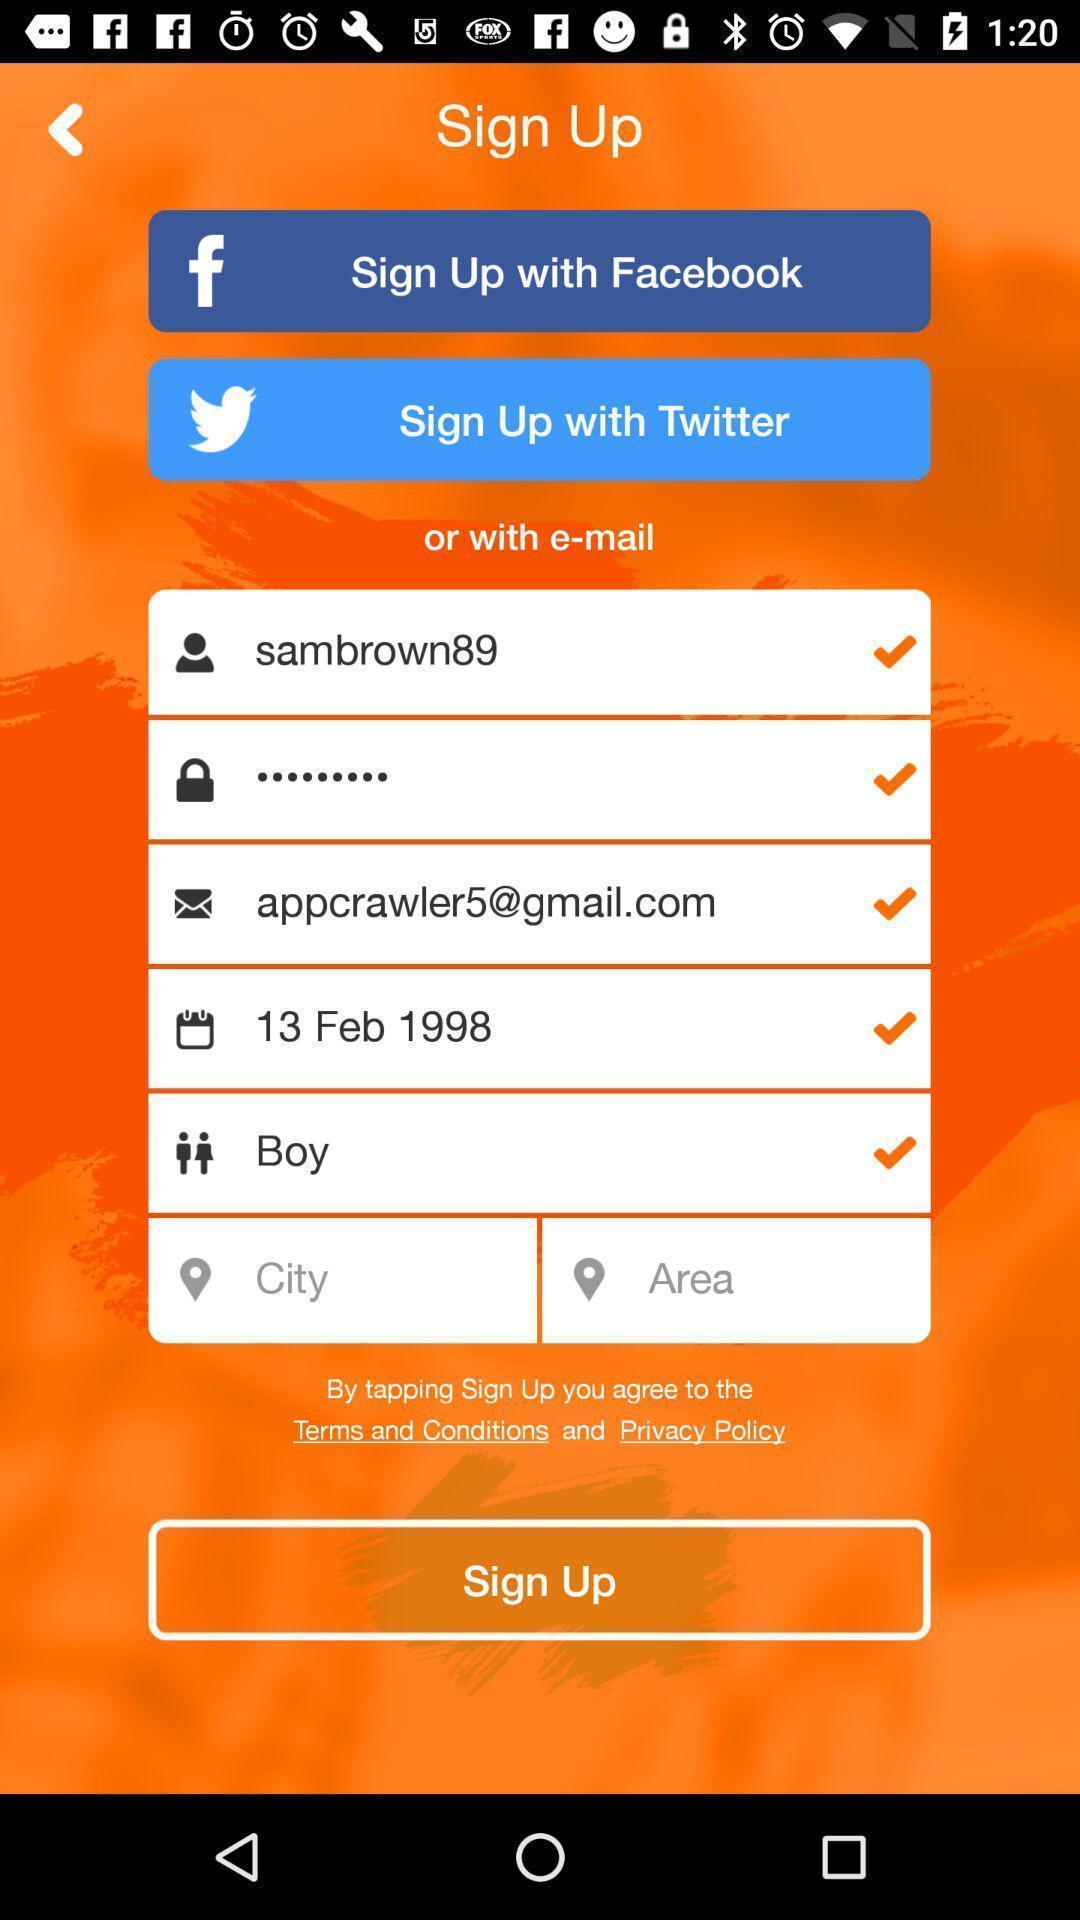Give me a summary of this screen capture. Signup page in a social app. 